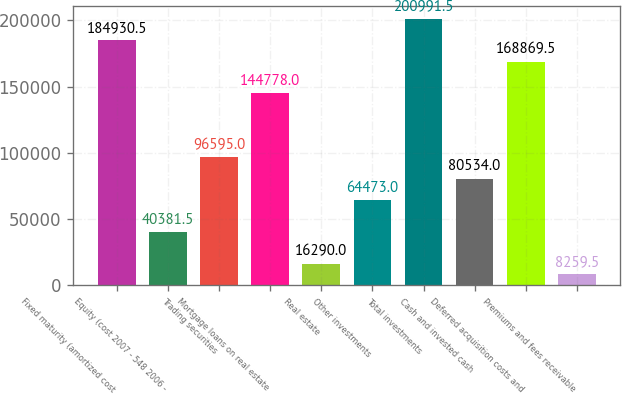<chart> <loc_0><loc_0><loc_500><loc_500><bar_chart><fcel>Fixed maturity (amortized cost<fcel>Equity (cost 2007 - 548 2006 -<fcel>Trading securities<fcel>Mortgage loans on real estate<fcel>Real estate<fcel>Other investments<fcel>Total investments<fcel>Cash and invested cash<fcel>Deferred acquisition costs and<fcel>Premiums and fees receivable<nl><fcel>184930<fcel>40381.5<fcel>96595<fcel>144778<fcel>16290<fcel>64473<fcel>200992<fcel>80534<fcel>168870<fcel>8259.5<nl></chart> 